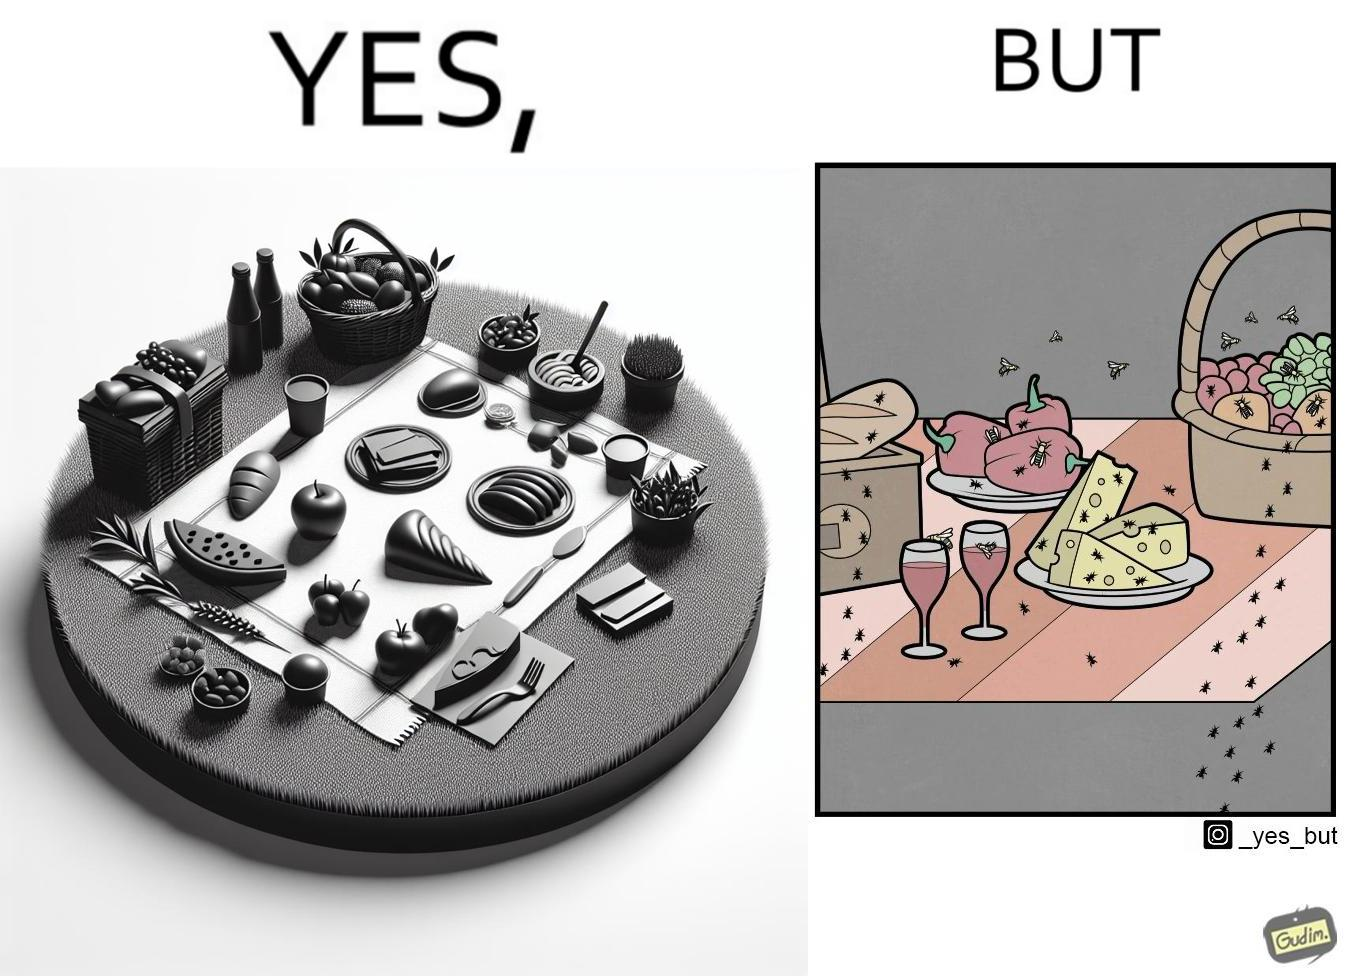What do you see in each half of this image? In the left part of the image: The food is kept on a blanket in a garden. In the right part of the image: Some bugs are attracting towards the food. 